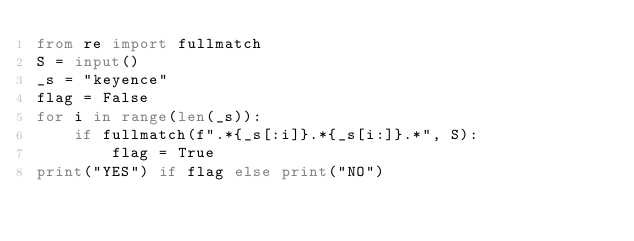Convert code to text. <code><loc_0><loc_0><loc_500><loc_500><_Python_>from re import fullmatch
S = input()
_s = "keyence"
flag = False
for i in range(len(_s)):
    if fullmatch(f".*{_s[:i]}.*{_s[i:]}.*", S):
        flag = True
print("YES") if flag else print("NO")
</code> 